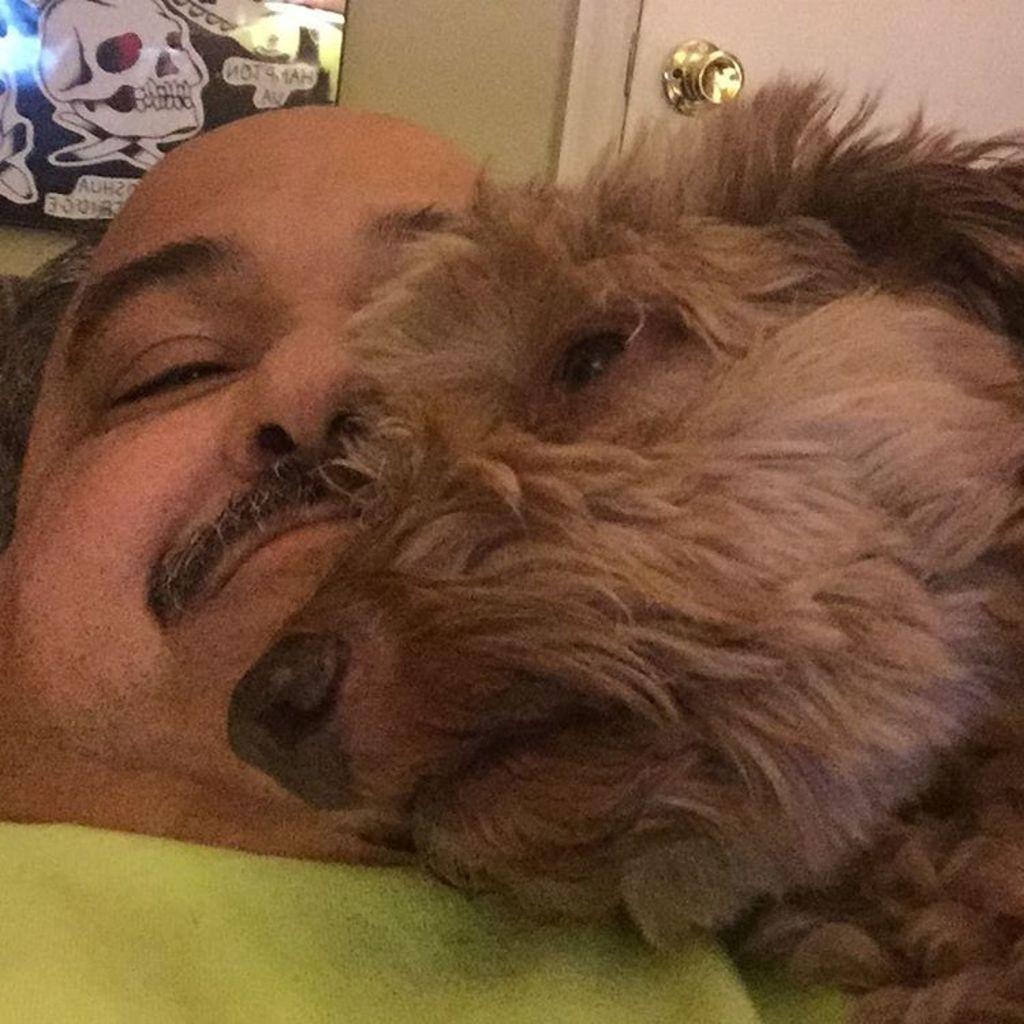Could you give a brief overview of what you see in this image? In this picture we can see a man, dog, wall painting and a door. 